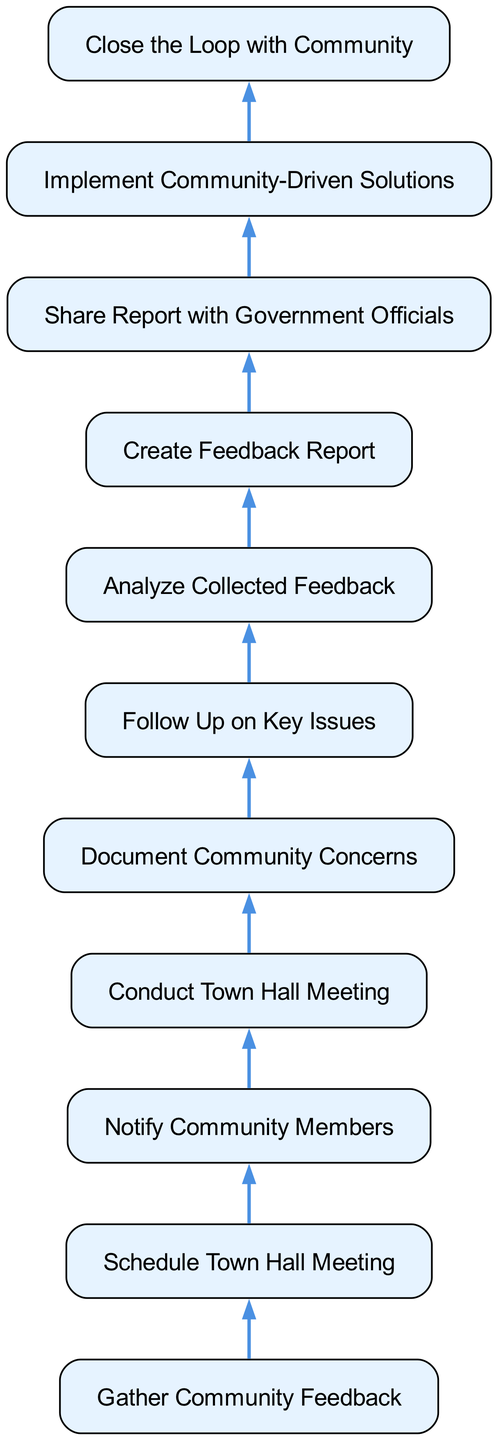what is the starting process in the flowchart? The flowchart begins with the node labeled "Gather Community Feedback." This is the first step that initiates the flow of the process.
Answer: Gather Community Feedback how many total processes are there in the diagram? The diagram contains a total of 11 processes, each represented by a distinct node in the flowchart.
Answer: 11 what follows after conducting the town hall meeting? After "Conduct Town Hall Meeting," the next process in the flow is "Document Community Concerns." This indicates that documenting concerns occurs directly after the meeting is conducted.
Answer: Document Community Concerns which process directly leads to the analysis of collected feedback? The process "Analyze Collected Feedback" directly follows the "Feedback Analysis" step, indicating that the feedback is analyzed immediately after being documented.
Answer: Feedback Analysis what is the final process in the flowchart? The flowchart concludes with the step "Close the Loop with Community," indicating the last action to be taken in the feedback collection process.
Answer: Close the Loop with Community which process comes before implementing community-driven solutions? The process that comes immediately before "Implement Community-Driven Solutions" is "Share Report with Government Officials," showing that the report must be shared before solutions can be implemented.
Answer: Share Report with Government Officials what is the relationship between scheduling a town hall meeting and notifying community members? The relationship is sequential: "Schedule Town Hall Meeting" must occur first before "Notify Community Members" can take place, as notifying the community is contingent on the scheduling of the meeting.
Answer: Sequential how many edges connect all the processes in the diagram? There are 10 edges connecting the 11 processes in the flowchart, showing the flow and sequence of the steps in the feedback collection process.
Answer: 10 which two processes are directly connected from documenting community concerns? The two processes that are directly connected from "Document Community Concerns" are "Follow Up on Key Issues" and "Analyze Collected Feedback," indicating that there are two paths from this step.
Answer: Follow Up on Key Issues and Analyze Collected Feedback 